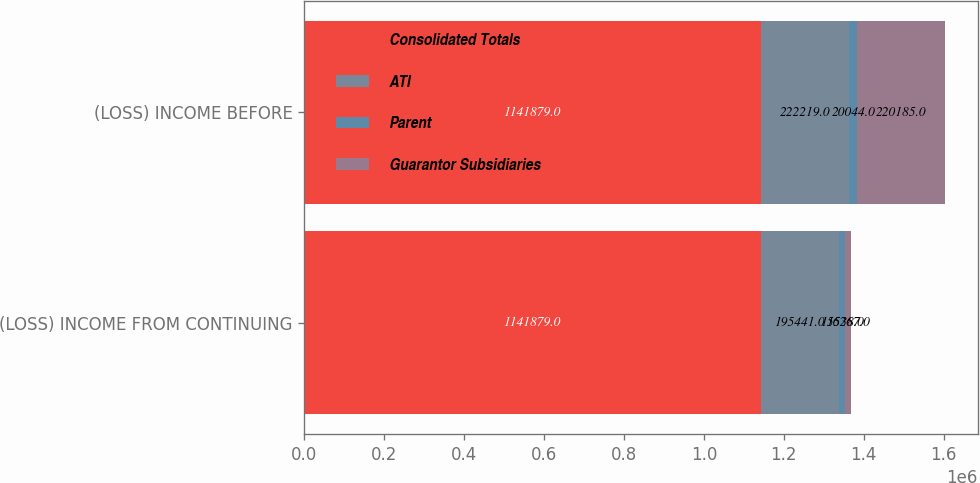<chart> <loc_0><loc_0><loc_500><loc_500><stacked_bar_chart><ecel><fcel>(LOSS) INCOME FROM CONTINUING<fcel>(LOSS) INCOME BEFORE<nl><fcel>Consolidated Totals<fcel>1.14188e+06<fcel>1.14188e+06<nl><fcel>ATI<fcel>195441<fcel>222219<nl><fcel>Parent<fcel>15538<fcel>20044<nl><fcel>Guarantor Subsidiaries<fcel>16267<fcel>220185<nl></chart> 